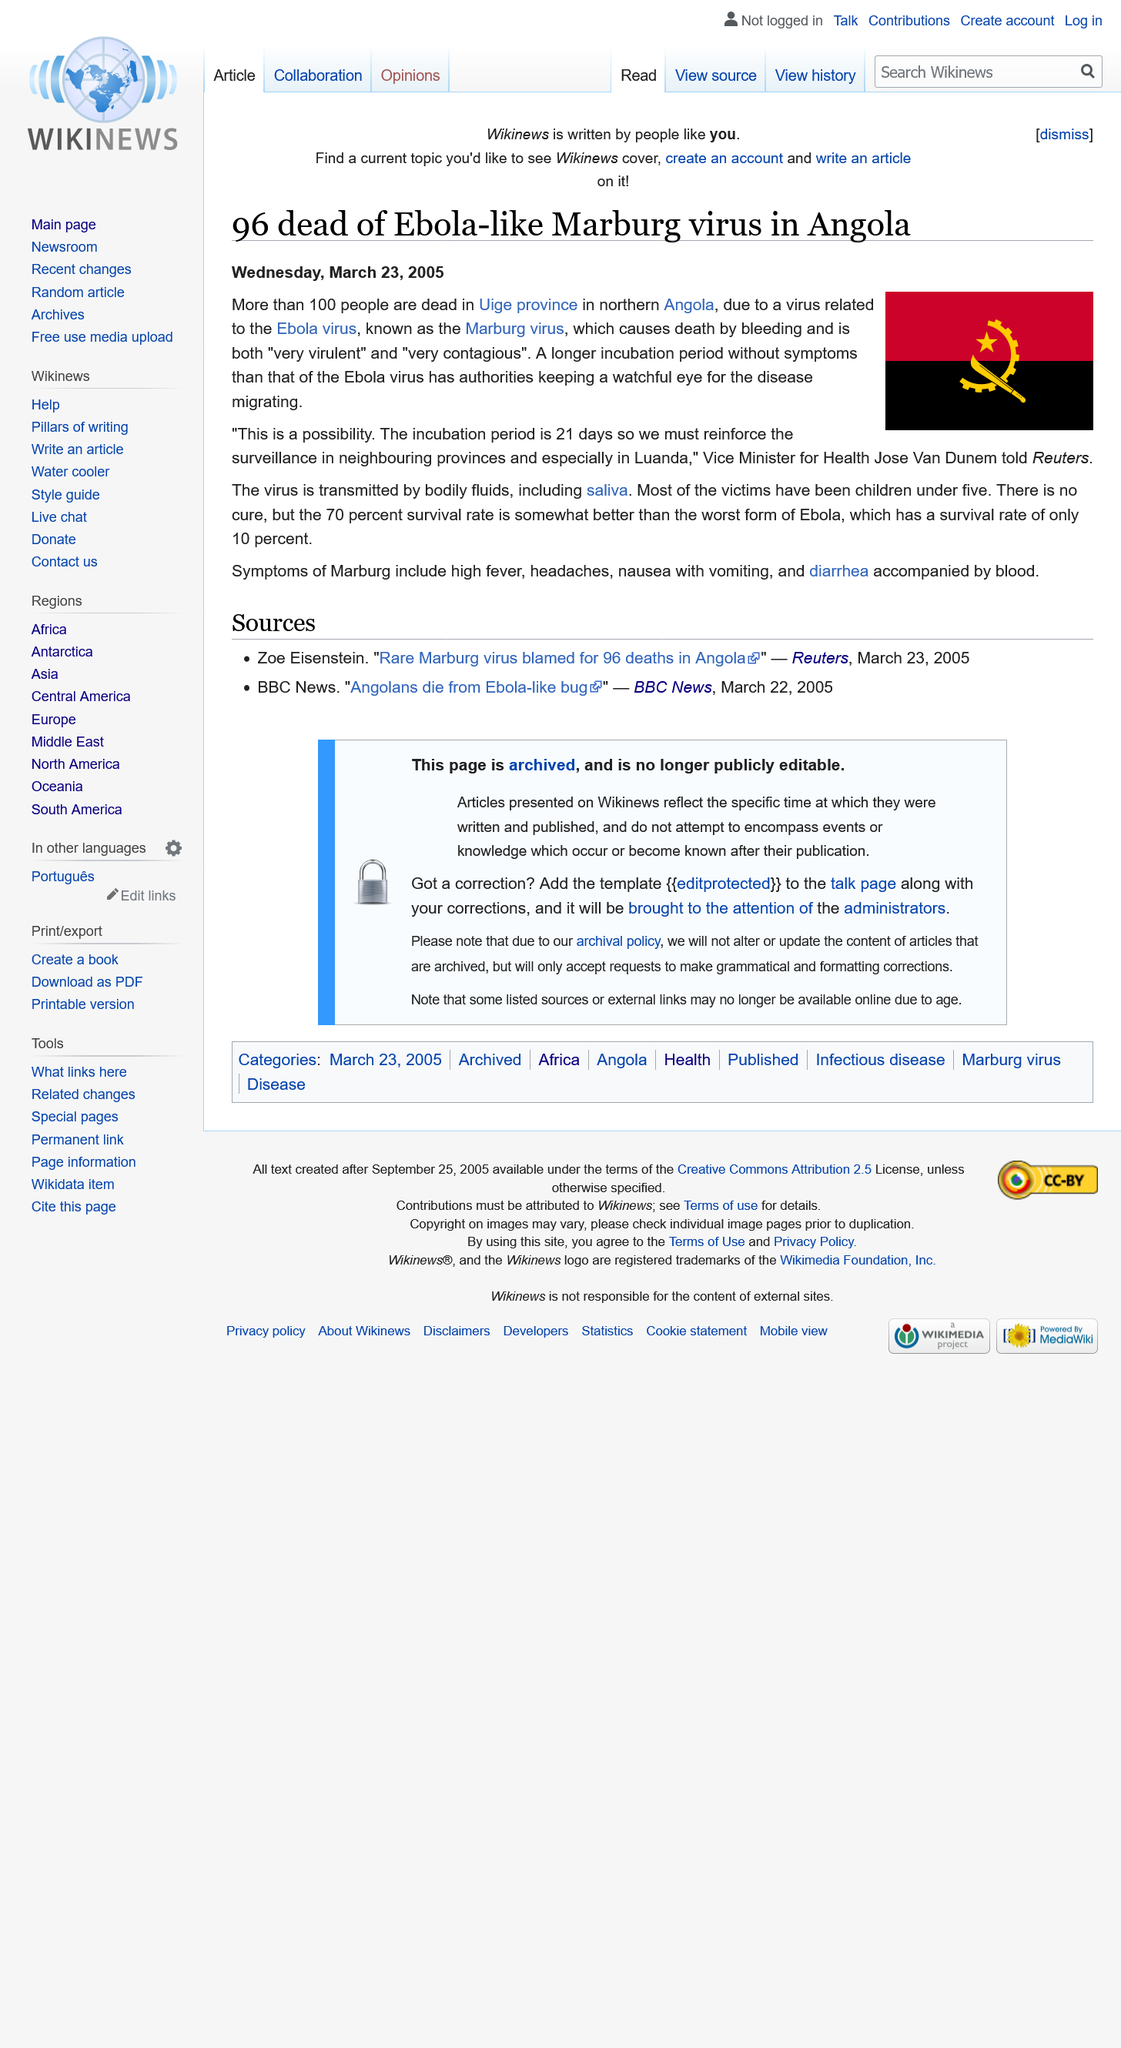Point out several critical features in this image. The Marbug virus is an Ebola-like virus that has been identified. Its name is the Marbug virus. The incubation period of the Marbug virus is 21 days. As of now, there have been at least 96 deaths caused by this virus, with more casualties expected to occur. 